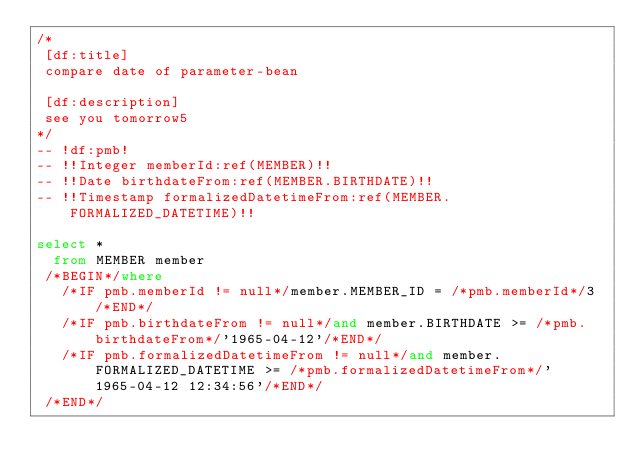Convert code to text. <code><loc_0><loc_0><loc_500><loc_500><_SQL_>/*
 [df:title]
 compare date of parameter-bean
 
 [df:description]
 see you tomorrow5
*/
-- !df:pmb!
-- !!Integer memberId:ref(MEMBER)!!
-- !!Date birthdateFrom:ref(MEMBER.BIRTHDATE)!!
-- !!Timestamp formalizedDatetimeFrom:ref(MEMBER.FORMALIZED_DATETIME)!!

select *
  from MEMBER member
 /*BEGIN*/where
   /*IF pmb.memberId != null*/member.MEMBER_ID = /*pmb.memberId*/3/*END*/
   /*IF pmb.birthdateFrom != null*/and member.BIRTHDATE >= /*pmb.birthdateFrom*/'1965-04-12'/*END*/
   /*IF pmb.formalizedDatetimeFrom != null*/and member.FORMALIZED_DATETIME >= /*pmb.formalizedDatetimeFrom*/'1965-04-12 12:34:56'/*END*/
 /*END*/</code> 